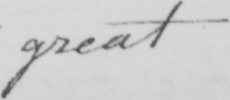Can you read and transcribe this handwriting? great 